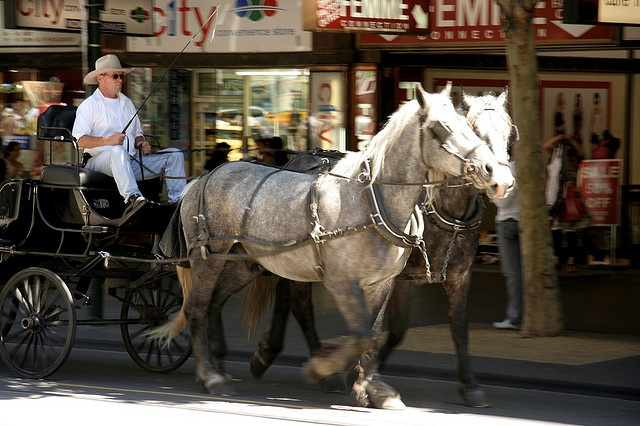Describe the objects in this image and their specific colors. I can see horse in black, gray, and darkgray tones, horse in black, white, and maroon tones, people in black, lavender, darkgray, and gray tones, people in black and gray tones, and people in black and gray tones in this image. 